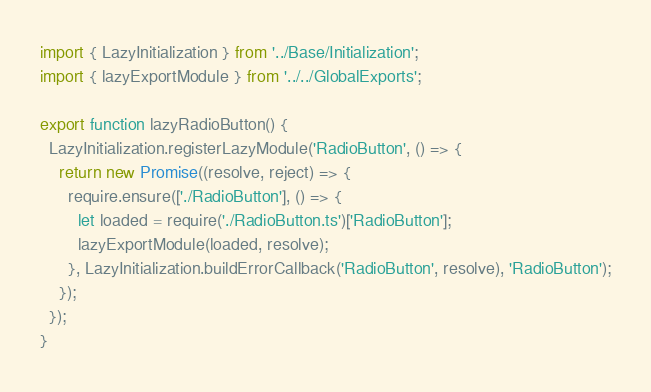<code> <loc_0><loc_0><loc_500><loc_500><_TypeScript_>import { LazyInitialization } from '../Base/Initialization';
import { lazyExportModule } from '../../GlobalExports';

export function lazyRadioButton() {
  LazyInitialization.registerLazyModule('RadioButton', () => {
    return new Promise((resolve, reject) => {
      require.ensure(['./RadioButton'], () => {
        let loaded = require('./RadioButton.ts')['RadioButton'];
        lazyExportModule(loaded, resolve);
      }, LazyInitialization.buildErrorCallback('RadioButton', resolve), 'RadioButton');
    });
  });
}
</code> 